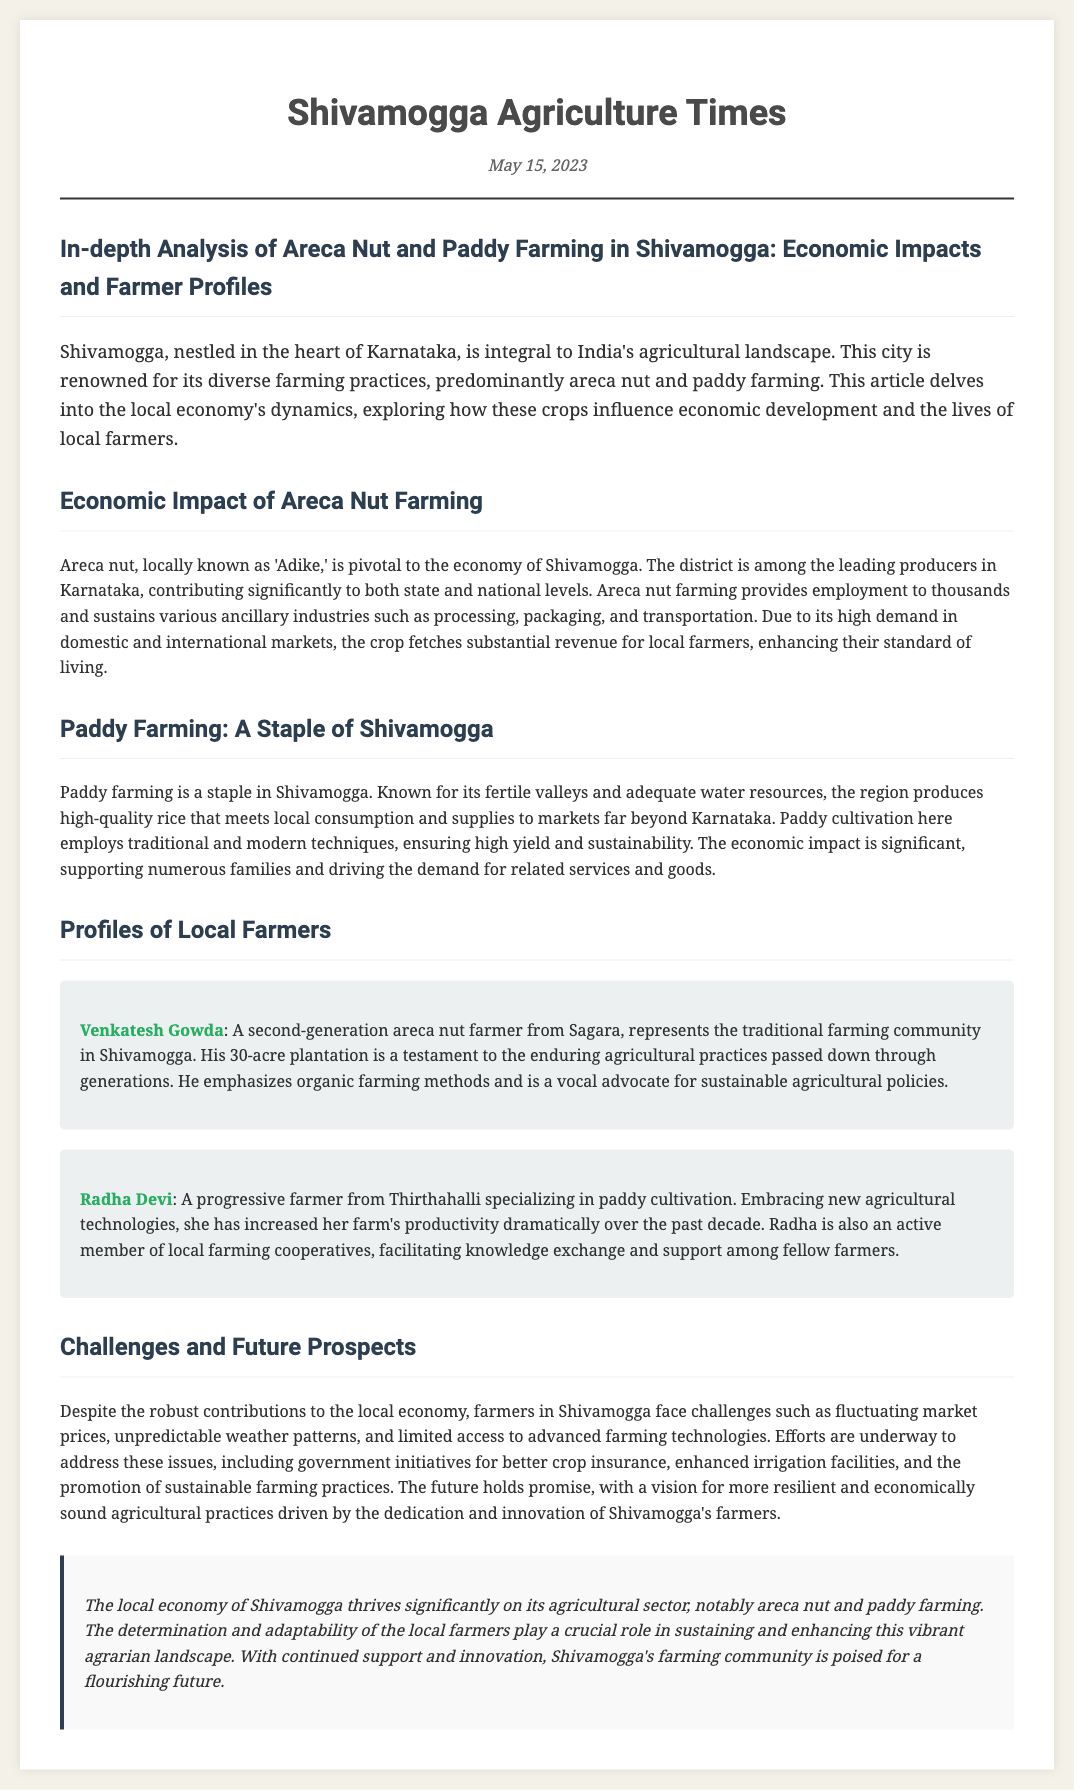what is the date of the article? The date mentioned in the article is located at the top of the document in the date section.
Answer: May 15, 2023 who is a second-generation areca nut farmer mentioned in the article? The article discusses Venkatesh Gowda as a second-generation areca nut farmer from Sagara.
Answer: Venkatesh Gowda what crop is Radha Devi specializing in? The article states that Radha Devi specializes in paddy cultivation.
Answer: paddy which farming method does Venkatesh Gowda emphasize? The document mentions that Venkatesh emphasizes organic farming methods.
Answer: organic farming how many acres is Venkatesh Gowda's plantation? The article reveals that Venkatesh Gowda has a 30-acre plantation.
Answer: 30 acres what region is known for high-quality rice production? The article discusses Shivamogga as the region known for high-quality rice production.
Answer: Shivamogga what is one challenge faced by farmers in Shivamogga? The article identifies fluctuating market prices, unpredictable weather, and limited access to advanced technologies as challenges.
Answer: fluctuating market prices what type of newspaper document is this? This document is structured as a newspaper article discussing local agriculture.
Answer: newspaper article what crop fetches substantial revenue for local farmers in Shivamogga? The document states that areca nut farming fetches substantial revenue for local farmers.
Answer: areca nut 